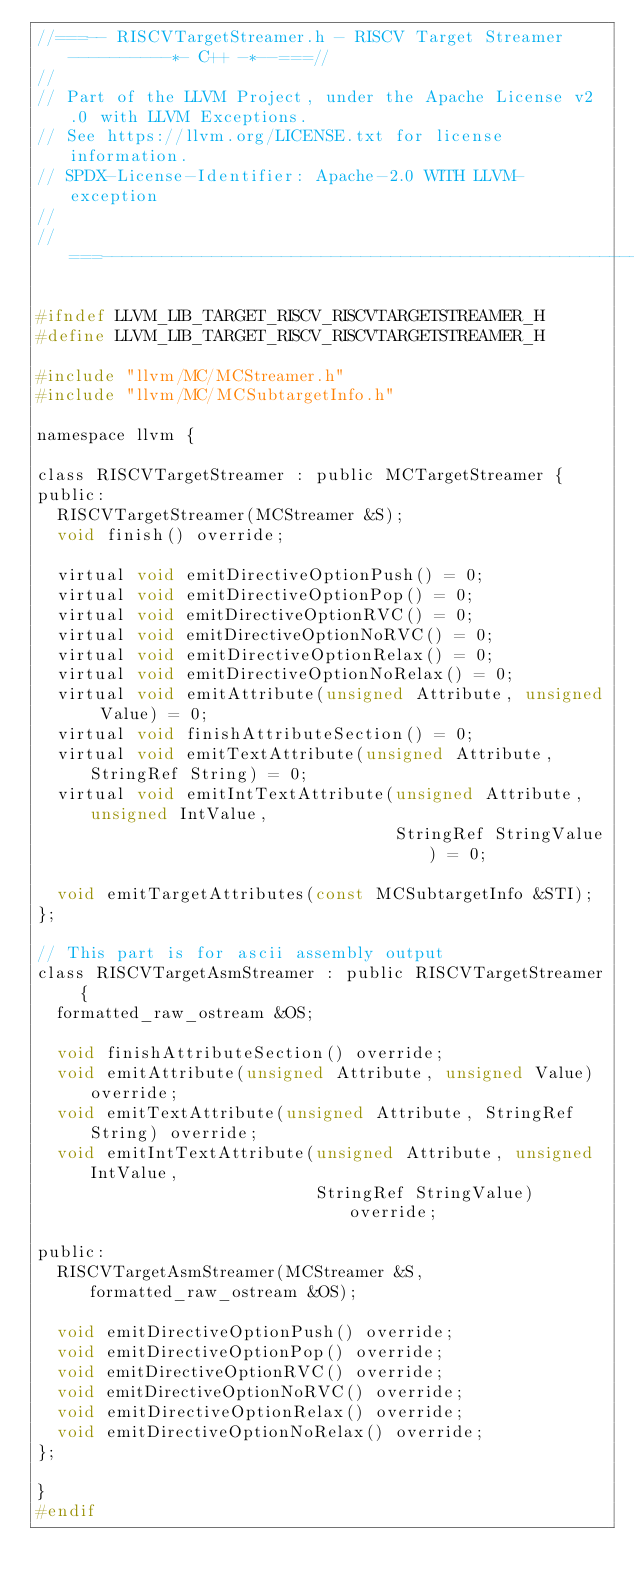<code> <loc_0><loc_0><loc_500><loc_500><_C_>//===-- RISCVTargetStreamer.h - RISCV Target Streamer ----------*- C++ -*--===//
//
// Part of the LLVM Project, under the Apache License v2.0 with LLVM Exceptions.
// See https://llvm.org/LICENSE.txt for license information.
// SPDX-License-Identifier: Apache-2.0 WITH LLVM-exception
//
//===----------------------------------------------------------------------===//

#ifndef LLVM_LIB_TARGET_RISCV_RISCVTARGETSTREAMER_H
#define LLVM_LIB_TARGET_RISCV_RISCVTARGETSTREAMER_H

#include "llvm/MC/MCStreamer.h"
#include "llvm/MC/MCSubtargetInfo.h"

namespace llvm {

class RISCVTargetStreamer : public MCTargetStreamer {
public:
  RISCVTargetStreamer(MCStreamer &S);
  void finish() override;

  virtual void emitDirectiveOptionPush() = 0;
  virtual void emitDirectiveOptionPop() = 0;
  virtual void emitDirectiveOptionRVC() = 0;
  virtual void emitDirectiveOptionNoRVC() = 0;
  virtual void emitDirectiveOptionRelax() = 0;
  virtual void emitDirectiveOptionNoRelax() = 0;
  virtual void emitAttribute(unsigned Attribute, unsigned Value) = 0;
  virtual void finishAttributeSection() = 0;
  virtual void emitTextAttribute(unsigned Attribute, StringRef String) = 0;
  virtual void emitIntTextAttribute(unsigned Attribute, unsigned IntValue,
                                    StringRef StringValue) = 0;

  void emitTargetAttributes(const MCSubtargetInfo &STI);
};

// This part is for ascii assembly output
class RISCVTargetAsmStreamer : public RISCVTargetStreamer {
  formatted_raw_ostream &OS;

  void finishAttributeSection() override;
  void emitAttribute(unsigned Attribute, unsigned Value) override;
  void emitTextAttribute(unsigned Attribute, StringRef String) override;
  void emitIntTextAttribute(unsigned Attribute, unsigned IntValue,
                            StringRef StringValue) override;

public:
  RISCVTargetAsmStreamer(MCStreamer &S, formatted_raw_ostream &OS);

  void emitDirectiveOptionPush() override;
  void emitDirectiveOptionPop() override;
  void emitDirectiveOptionRVC() override;
  void emitDirectiveOptionNoRVC() override;
  void emitDirectiveOptionRelax() override;
  void emitDirectiveOptionNoRelax() override;
};

}
#endif
</code> 